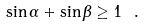Convert formula to latex. <formula><loc_0><loc_0><loc_500><loc_500>\sin \alpha + \sin \beta \geq 1 \ .</formula> 